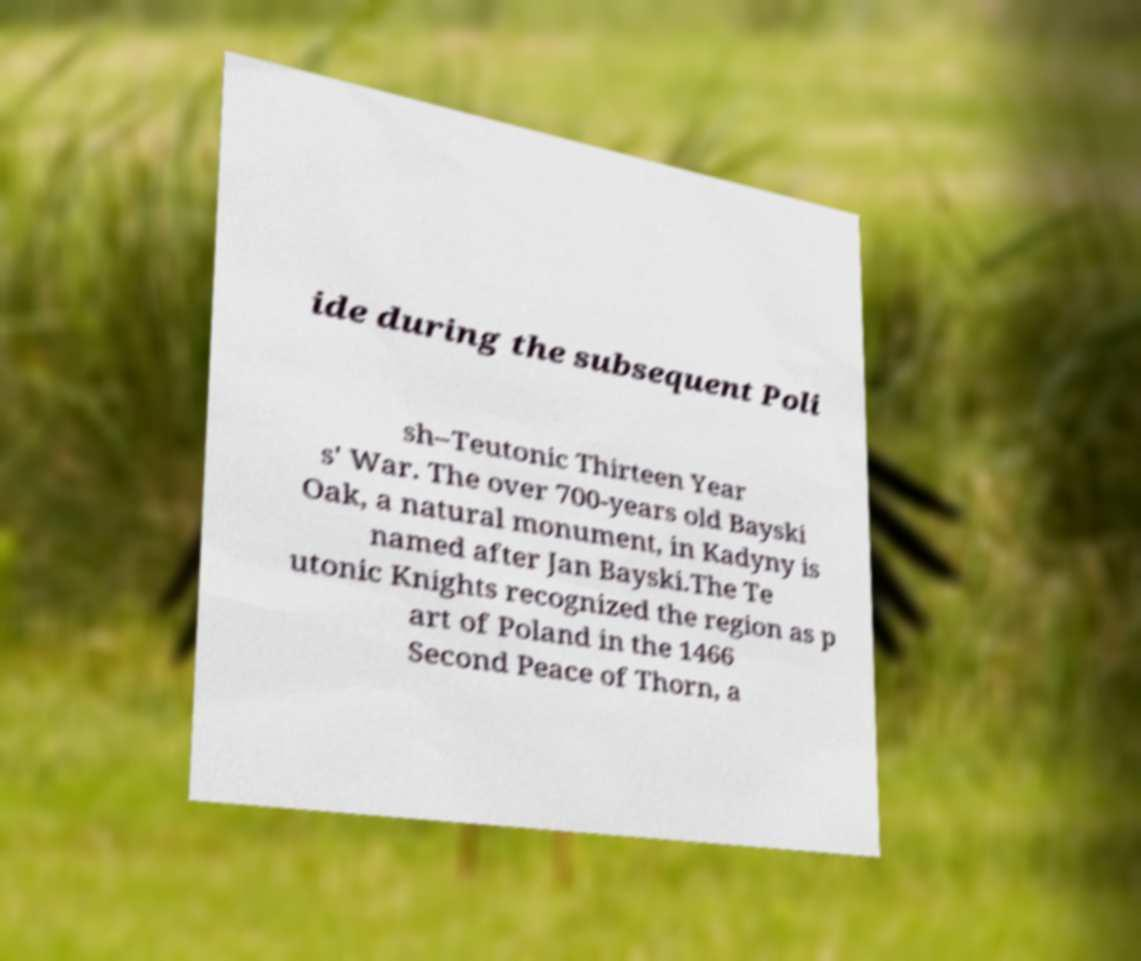Could you extract and type out the text from this image? ide during the subsequent Poli sh–Teutonic Thirteen Year s' War. The over 700-years old Bayski Oak, a natural monument, in Kadyny is named after Jan Bayski.The Te utonic Knights recognized the region as p art of Poland in the 1466 Second Peace of Thorn, a 